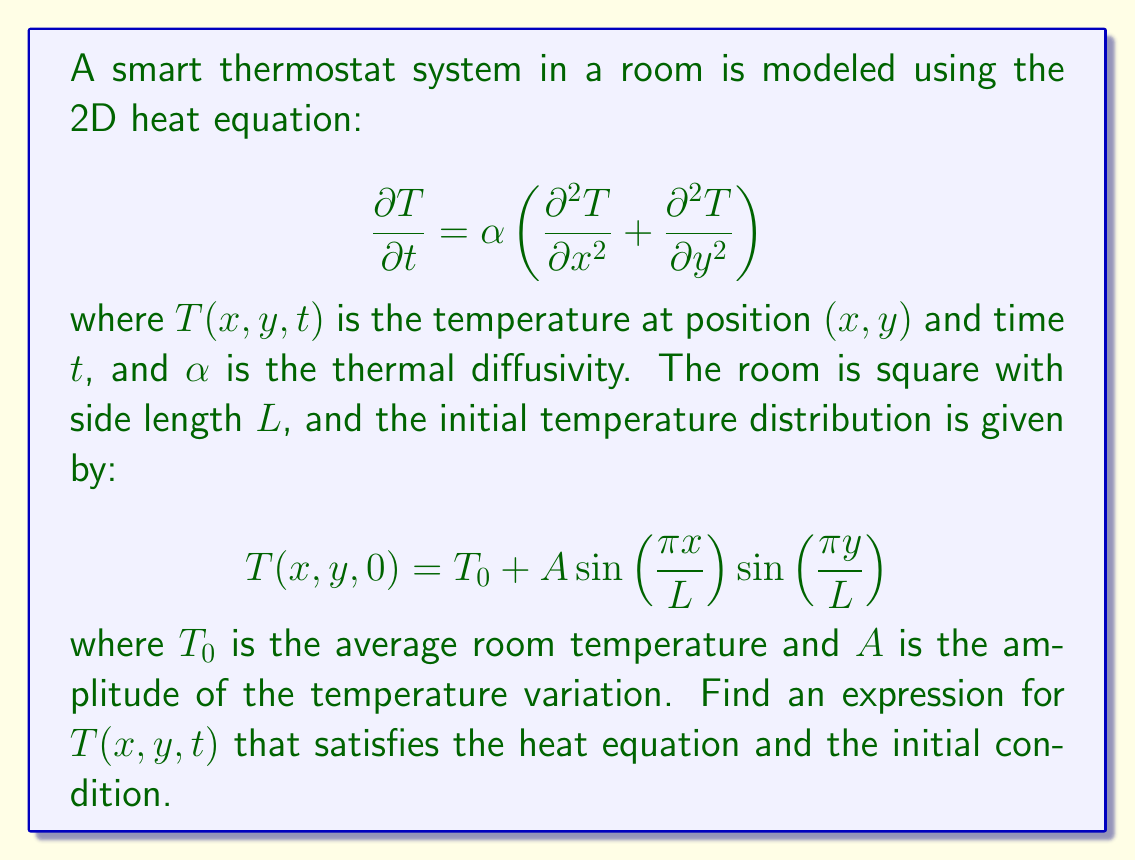Show me your answer to this math problem. To solve this problem, we'll use the method of separation of variables:

1) Assume a solution of the form $T(x,y,t) = X(x)Y(y)Z(t)$.

2) Substituting this into the heat equation:

   $$XYZ' = \alpha(X''Y + XY'')Z$$

3) Dividing by $XYZ$:

   $$\frac{Z'}{Z} = \alpha\left(\frac{X''}{X} + \frac{Y''}{Y}\right)$$

4) The left side is a function of $t$ only, and the right side is a function of $x$ and $y$ only. For this to be true for all $x$, $y$, and $t$, both sides must equal a constant. Let's call this constant $-k^2$:

   $$\frac{Z'}{Z} = -\alpha k^2$$
   $$\frac{X''}{X} + \frac{Y''}{Y} = -k^2$$

5) From the $Z$ equation:
   
   $$Z(t) = Ce^{-\alpha k^2 t}$$

6) The $X$ and $Y$ equations are similar:

   $$\frac{X''}{X} = -k_x^2, \quad \frac{Y''}{Y} = -k_y^2$$
   
   where $k_x^2 + k_y^2 = k^2$

7) The solutions are:

   $$X(x) = A_x \sin(k_x x) + B_x \cos(k_x x)$$
   $$Y(y) = A_y \sin(k_y y) + B_y \cos(k_y y)$$

8) Given the initial condition, we can see that $k_x = k_y = \frac{\pi}{L}$, and $k^2 = 2(\frac{\pi}{L})^2$.

9) The complete solution is:

   $$T(x,y,t) = T_0 + A \sin\left(\frac{\pi x}{L}\right) \sin\left(\frac{\pi y}{L}\right) e^{-2\alpha(\frac{\pi}{L})^2 t}$$

This satisfies both the heat equation and the initial condition.
Answer: $T(x,y,t) = T_0 + A \sin\left(\frac{\pi x}{L}\right) \sin\left(\frac{\pi y}{L}\right) e^{-2\alpha(\frac{\pi}{L})^2 t}$ 